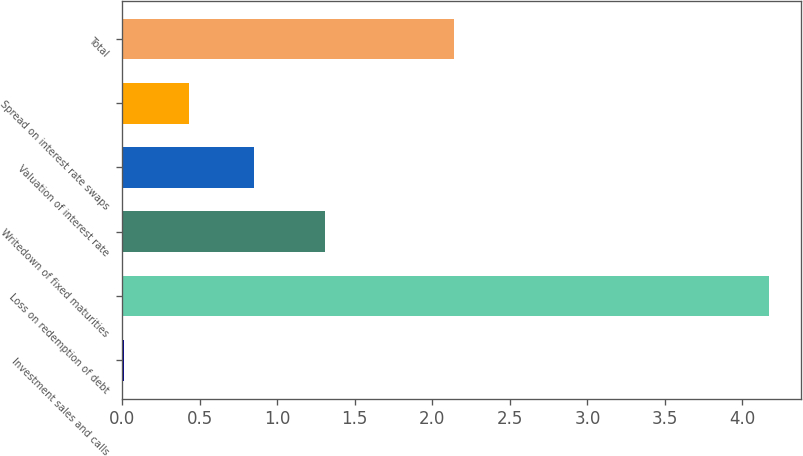Convert chart to OTSL. <chart><loc_0><loc_0><loc_500><loc_500><bar_chart><fcel>Investment sales and calls<fcel>Loss on redemption of debt<fcel>Writedown of fixed maturities<fcel>Valuation of interest rate<fcel>Spread on interest rate swaps<fcel>Total<nl><fcel>0.01<fcel>4.17<fcel>1.31<fcel>0.85<fcel>0.43<fcel>2.14<nl></chart> 